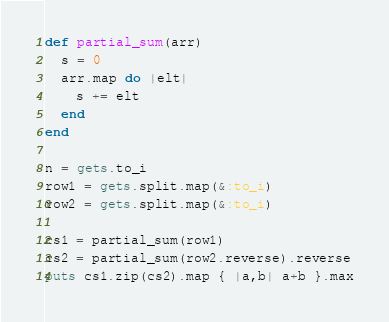Convert code to text. <code><loc_0><loc_0><loc_500><loc_500><_Ruby_>def partial_sum(arr)
  s = 0
  arr.map do |elt|
    s += elt
  end
end

n = gets.to_i
row1 = gets.split.map(&:to_i)
row2 = gets.split.map(&:to_i)

cs1 = partial_sum(row1)
cs2 = partial_sum(row2.reverse).reverse
puts cs1.zip(cs2).map { |a,b| a+b }.max
</code> 